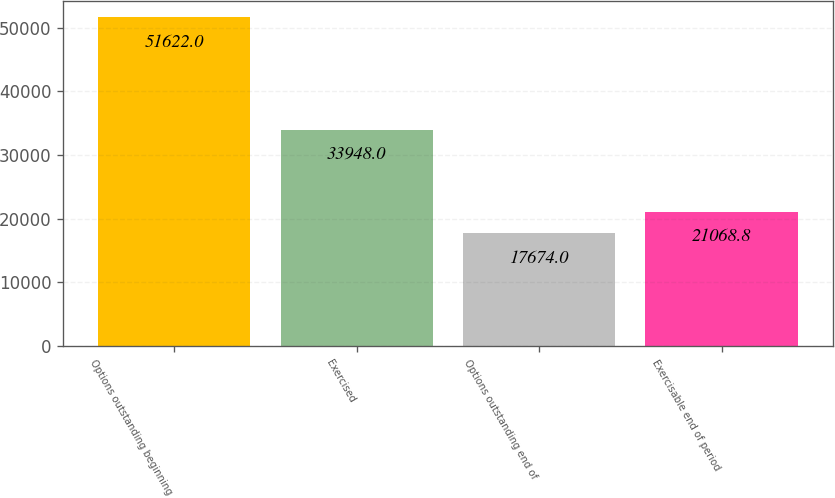Convert chart to OTSL. <chart><loc_0><loc_0><loc_500><loc_500><bar_chart><fcel>Options outstanding beginning<fcel>Exercised<fcel>Options outstanding end of<fcel>Exercisable end of period<nl><fcel>51622<fcel>33948<fcel>17674<fcel>21068.8<nl></chart> 